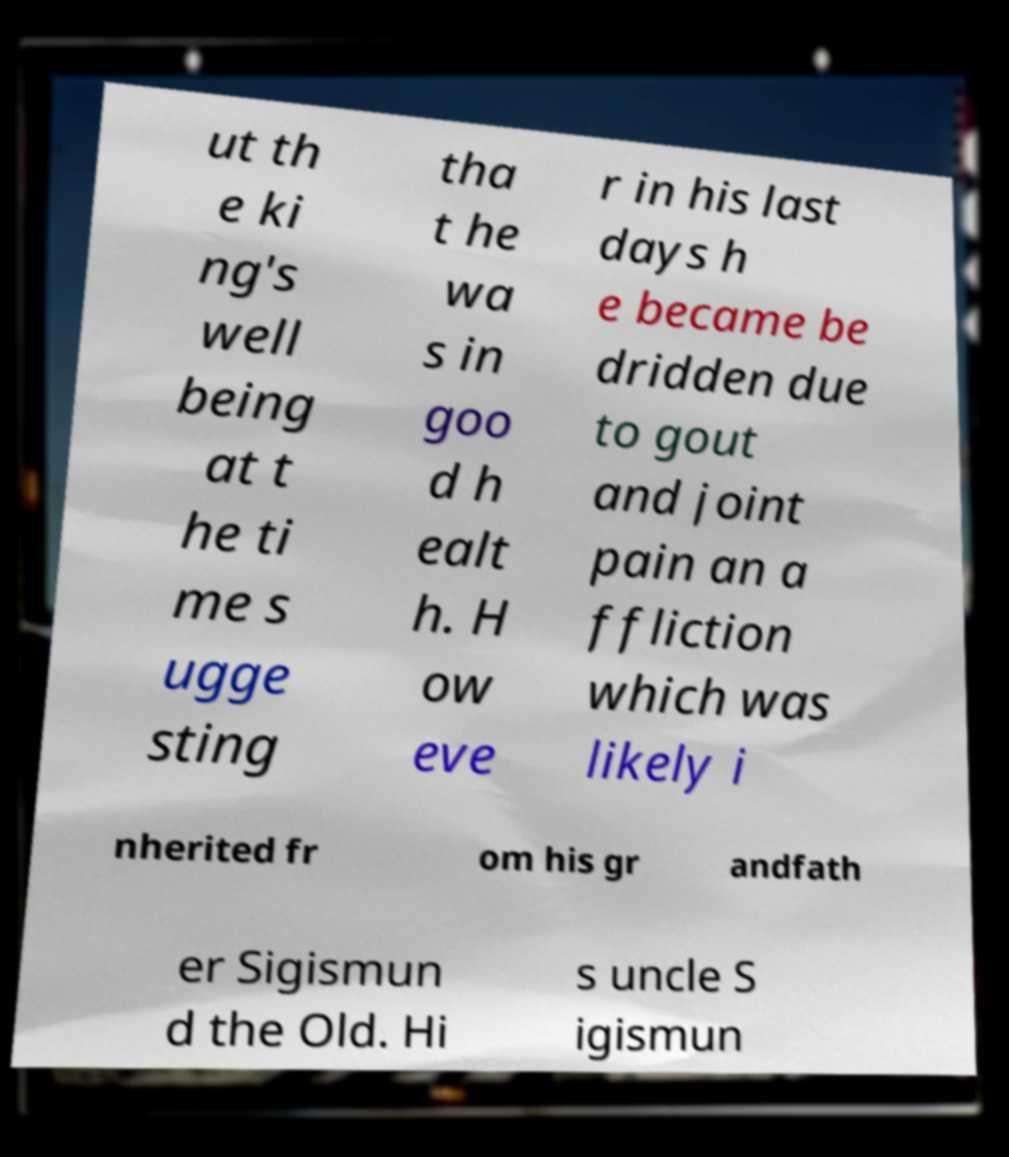Could you assist in decoding the text presented in this image and type it out clearly? ut th e ki ng's well being at t he ti me s ugge sting tha t he wa s in goo d h ealt h. H ow eve r in his last days h e became be dridden due to gout and joint pain an a ffliction which was likely i nherited fr om his gr andfath er Sigismun d the Old. Hi s uncle S igismun 